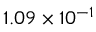<formula> <loc_0><loc_0><loc_500><loc_500>1 . 0 9 \times 1 0 ^ { - 1 }</formula> 